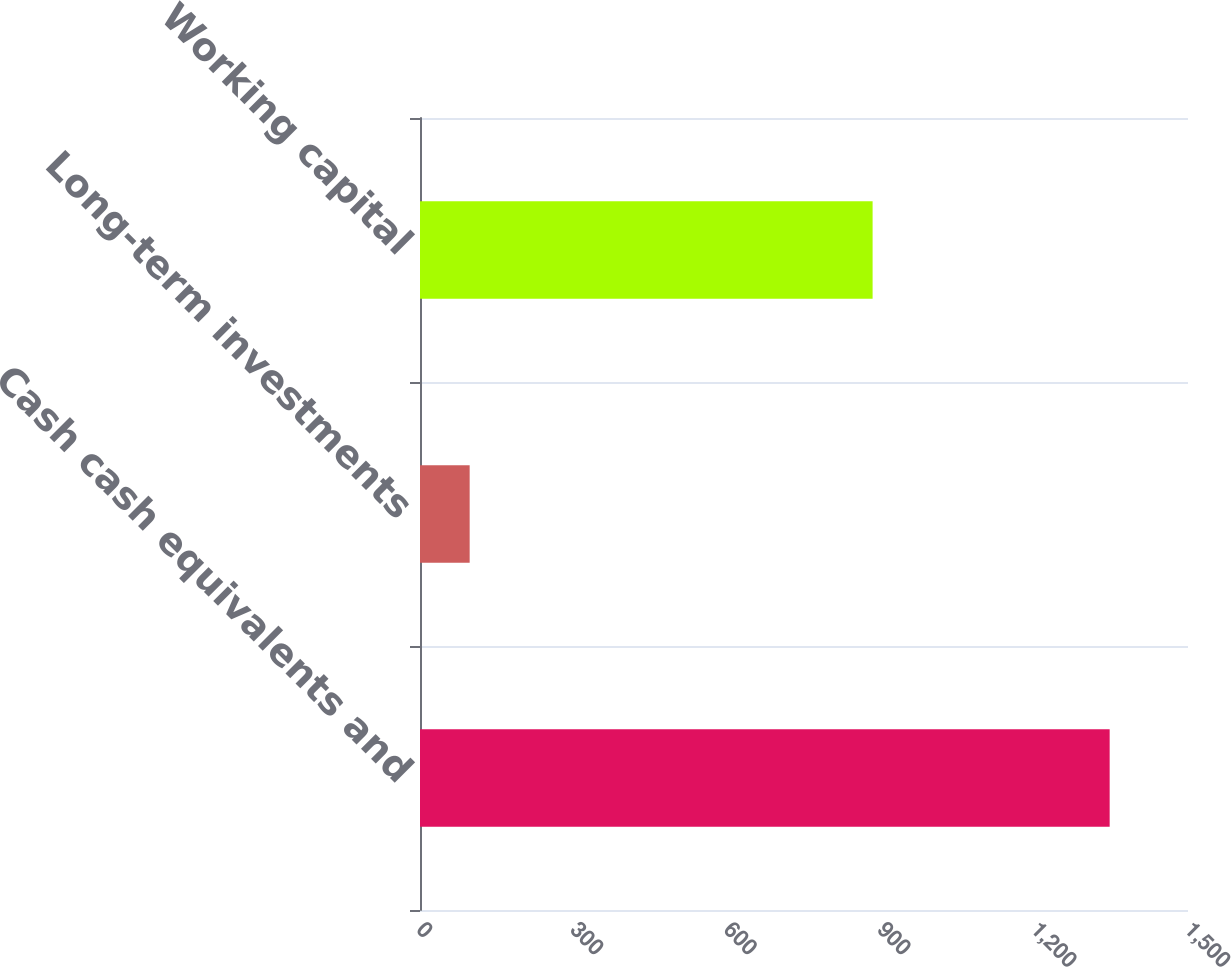Convert chart. <chart><loc_0><loc_0><loc_500><loc_500><bar_chart><fcel>Cash cash equivalents and<fcel>Long-term investments<fcel>Working capital<nl><fcel>1347<fcel>97<fcel>884<nl></chart> 